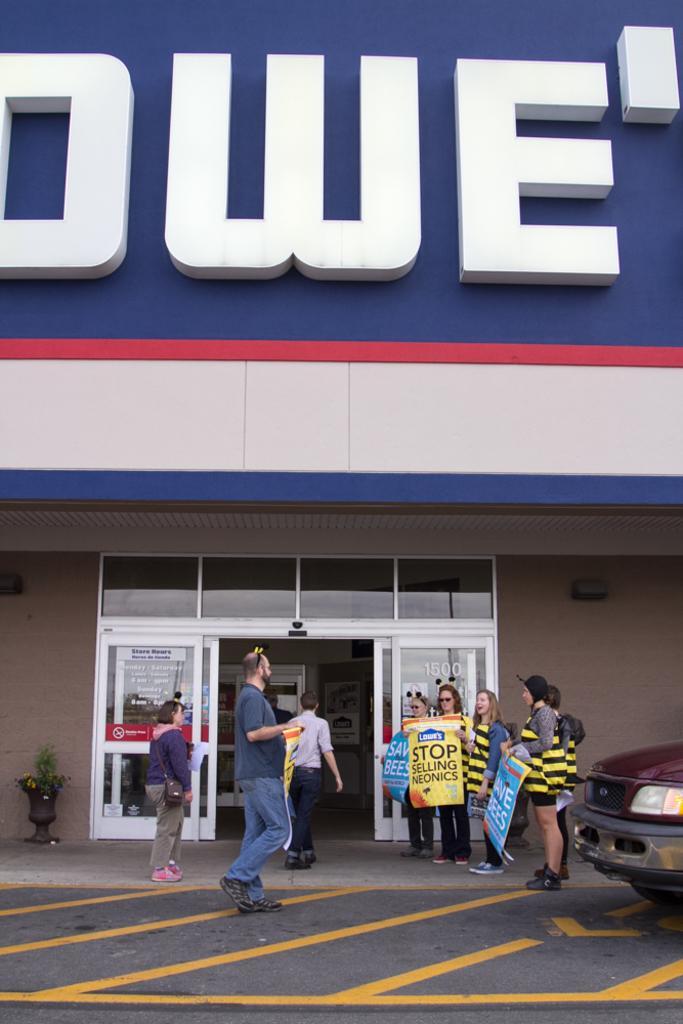How would you summarize this image in a sentence or two? In this picture we can see people and a vehicle on the road and few people are holding posters and in the background we can see a houseplant and a building. 